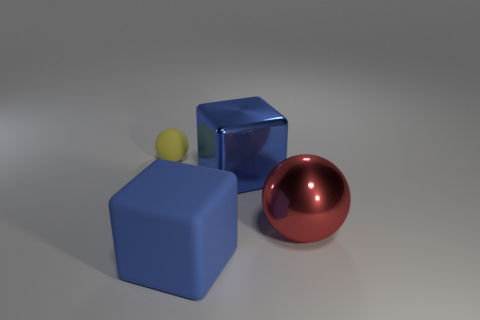Add 2 small rubber objects. How many objects exist? 6 Add 1 tiny matte objects. How many tiny matte objects are left? 2 Add 2 small things. How many small things exist? 3 Subtract 0 gray blocks. How many objects are left? 4 Subtract all big brown shiny cylinders. Subtract all shiny spheres. How many objects are left? 3 